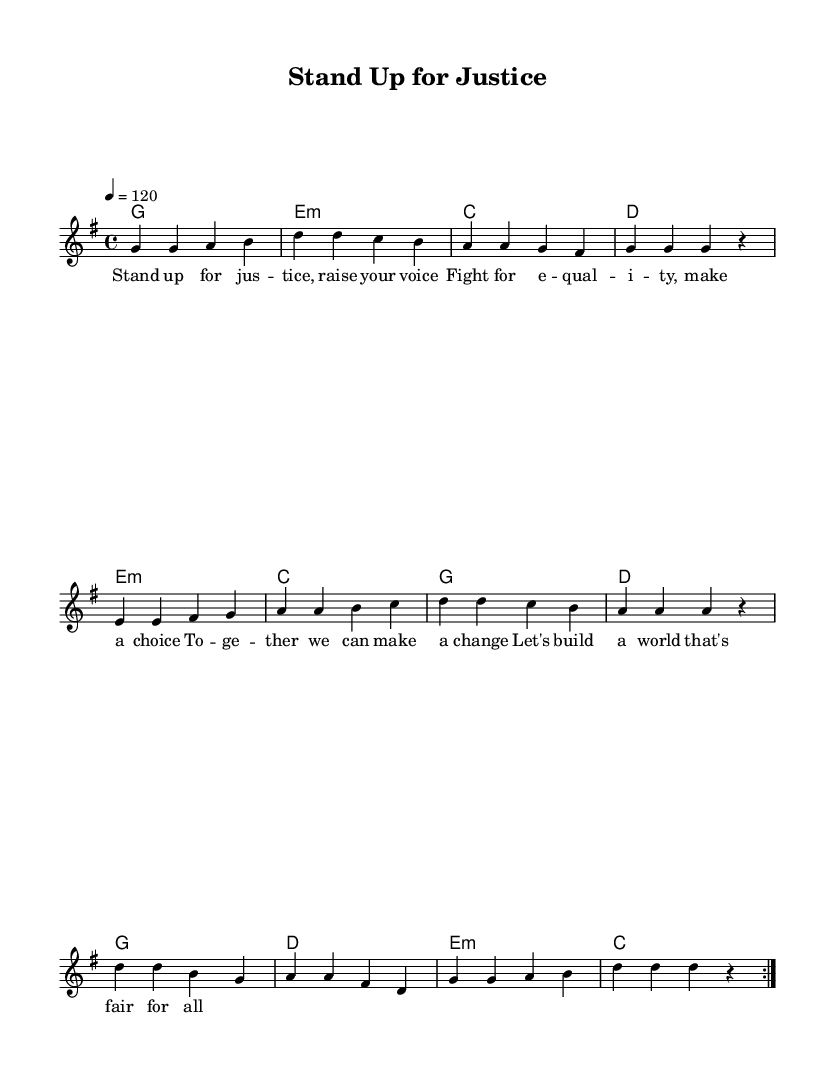What is the key signature of this music? The key signature is G major, which contains one sharp (F#).
Answer: G major What is the time signature of this piece? The time signature is 4/4, indicating four beats per measure.
Answer: 4/4 What is the tempo marking indicated in the sheet music? The tempo marking is a quarter note equals 120, denoting the speed at which to perform the piece.
Answer: 120 How many verses are repeated in the melody? The melody contains two repetitions of the verse section, as indicated by \repeat volta 2.
Answer: 2 What is the last chord of the chorus? The last chord of the chorus is C major. The visual layout shows the chord sequence leading to this conclusion.
Answer: C What lyrical theme is emphasized in the song? The lyrics focus on justice and equality, urging people to stand together for social change.
Answer: Justice and equality What is the function of the pre-chorus in this composition? The pre-chorus serves as a transition section that builds up to the chorus, enhancing emotional intensity and preparing the listener for the main message.
Answer: Transition 